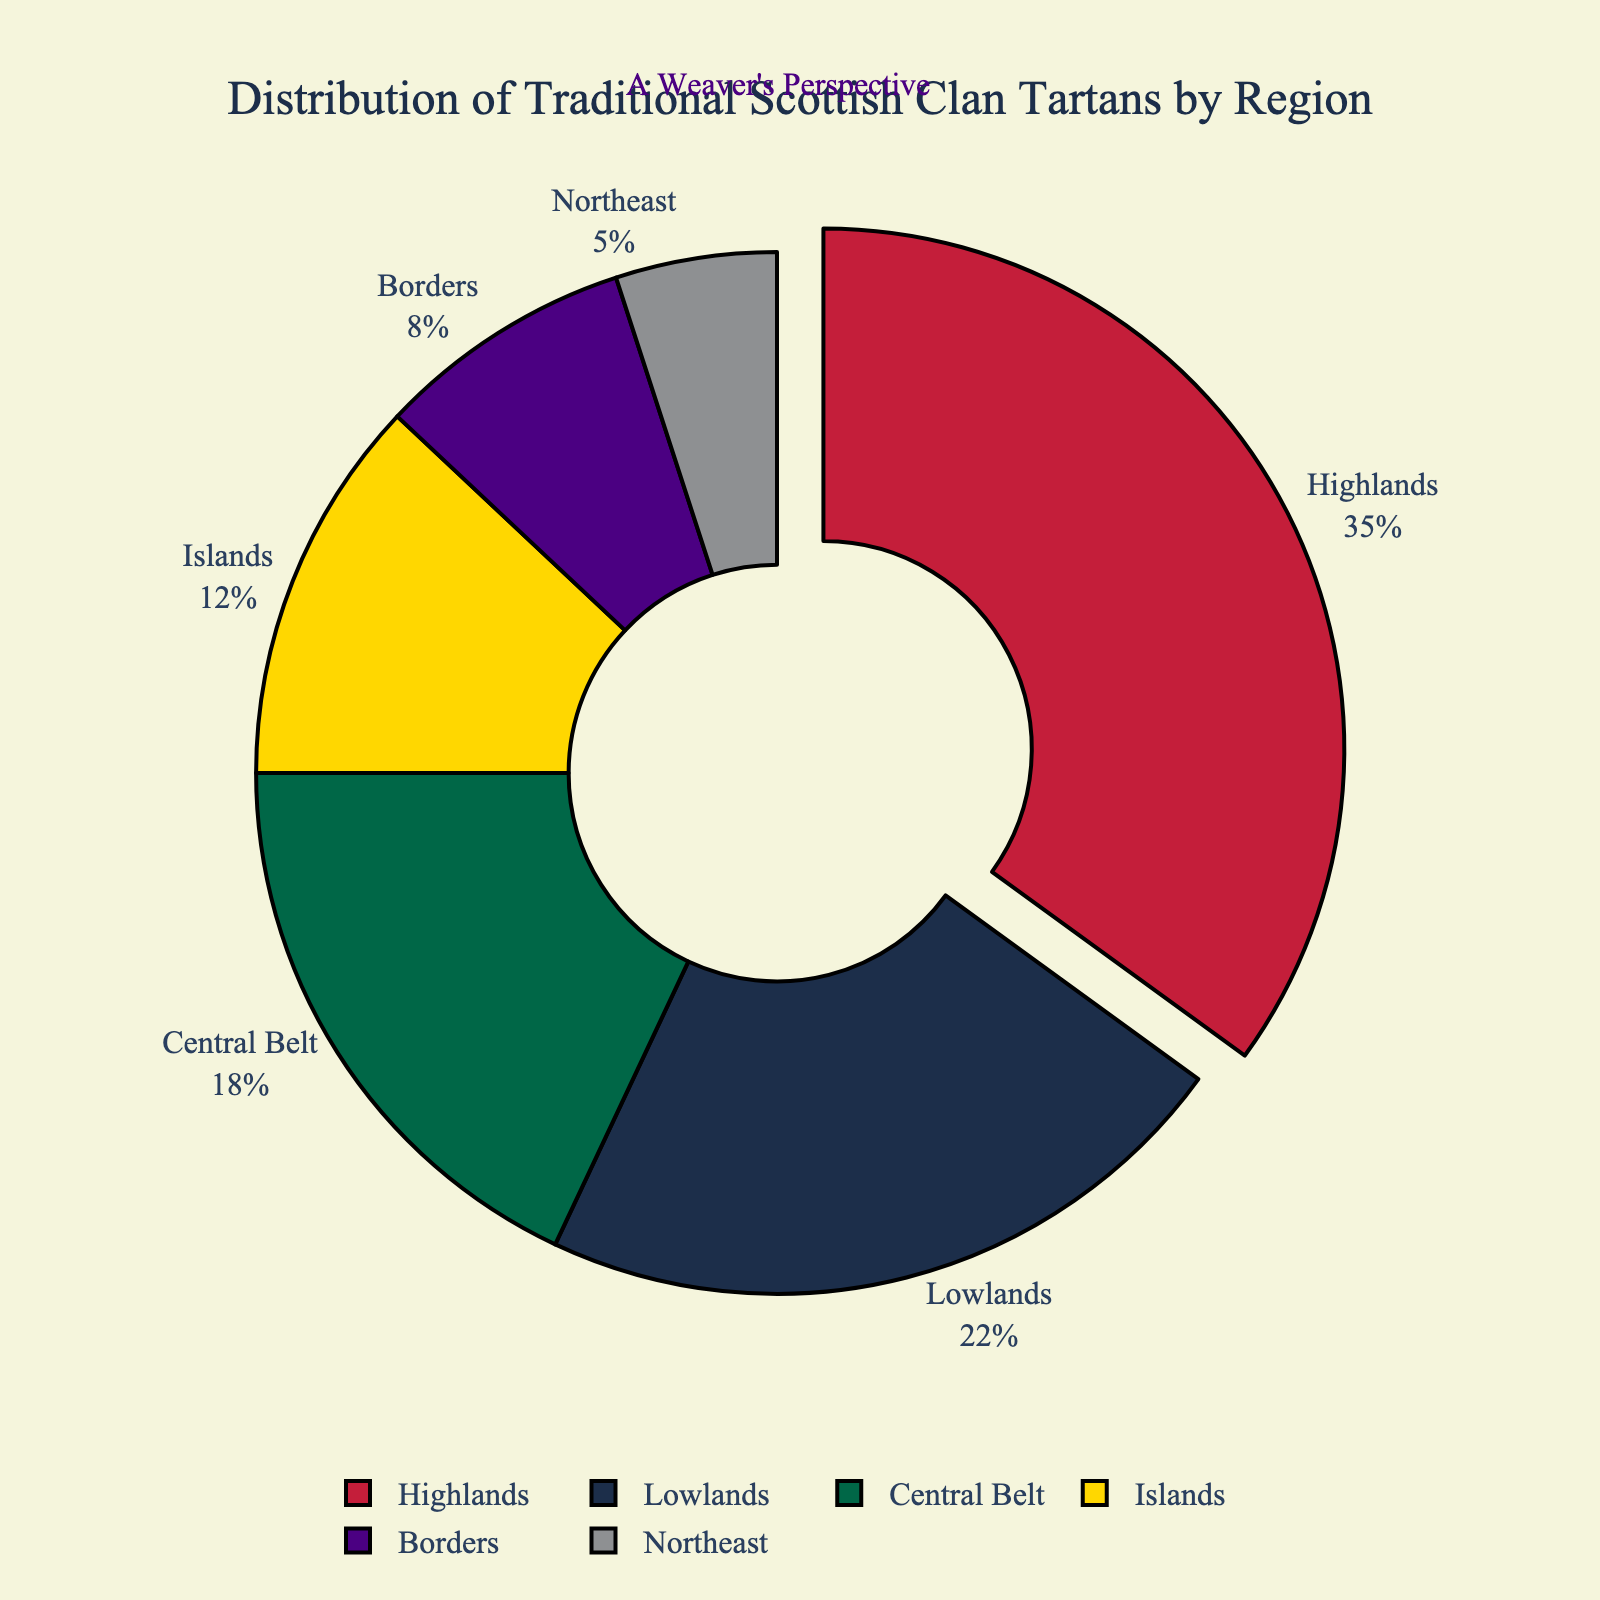Which region has the highest percentage of traditional Scottish clan tartans? The region with the highest percentage of traditional Scottish clan tartans is shown by the largest slice in the pie chart. This is the Highlands.
Answer: Highlands Which region has the smallest percentage of traditional Scottish clan tartans? The region with the smallest percentage is represented by the smallest slice in the pie chart. This is the Northeast.
Answer: Northeast How does the percentage of the Central Belt compare to the Lowlands? By looking at the pie chart, we see that the Central Belt's slice is smaller than the Lowlands' slice. The Central Belt has 18% while the Lowlands have 22%.
Answer: Central Belt is smaller What percentage of the pie chart is made up by the Islands and Borders regions combined? Combine the percentages for the Islands (12%) and Borders (8%) by adding them: 12 + 8 = 20%.
Answer: 20% What is the difference in percentage between the Highlands and the Islands? Subtract the Islands' percentage from the Highlands' percentage: 35% - 12% = 23%.
Answer: 23% Which regions together make up less than 30% of the traditional Scottish clan tartans? Add the percentages of smaller slices until reaching 30%. Borders (8%), Northeast (5%), and Islands (12%) together make 8 + 5 + 12 = 25%. Adding Central Belt's 18% would exceed 30%, so the regions are Borders, Northeast, and Islands.
Answer: Borders, Northeast, Islands If you were to combine the Lowlands and Central Belt regions, what portion of the chart would they represent together? Add the percentages of the Lowlands (22%) and Central Belt (18%): 22 + 18 = 40%.
Answer: 40% Which regions make up more than half of the pie chart in total? Calculate the sum of the percentages for the regions until exceeding 50%. Starting with the Highlands (35%) and then adding the Lowlands (22%) gives 35 + 22 = 57%. No need to add more regions.
Answer: Highlands, Lowlands What color represents the region with the second-highest percentage? The region with the second-highest percentage is the Lowlands. By looking at the color of its slice, it is represented in blue.
Answer: Blue If the Highlands' percentage decreased by 10%, how would its new percentage compare to the Central Belt's percentage? Subtract 10% from the Highlands' current 35%: 35 - 10 = 25%. Compare it to the Central Belt's 18%: 25% is greater than 18%.
Answer: Highlands' new percentage is greater 